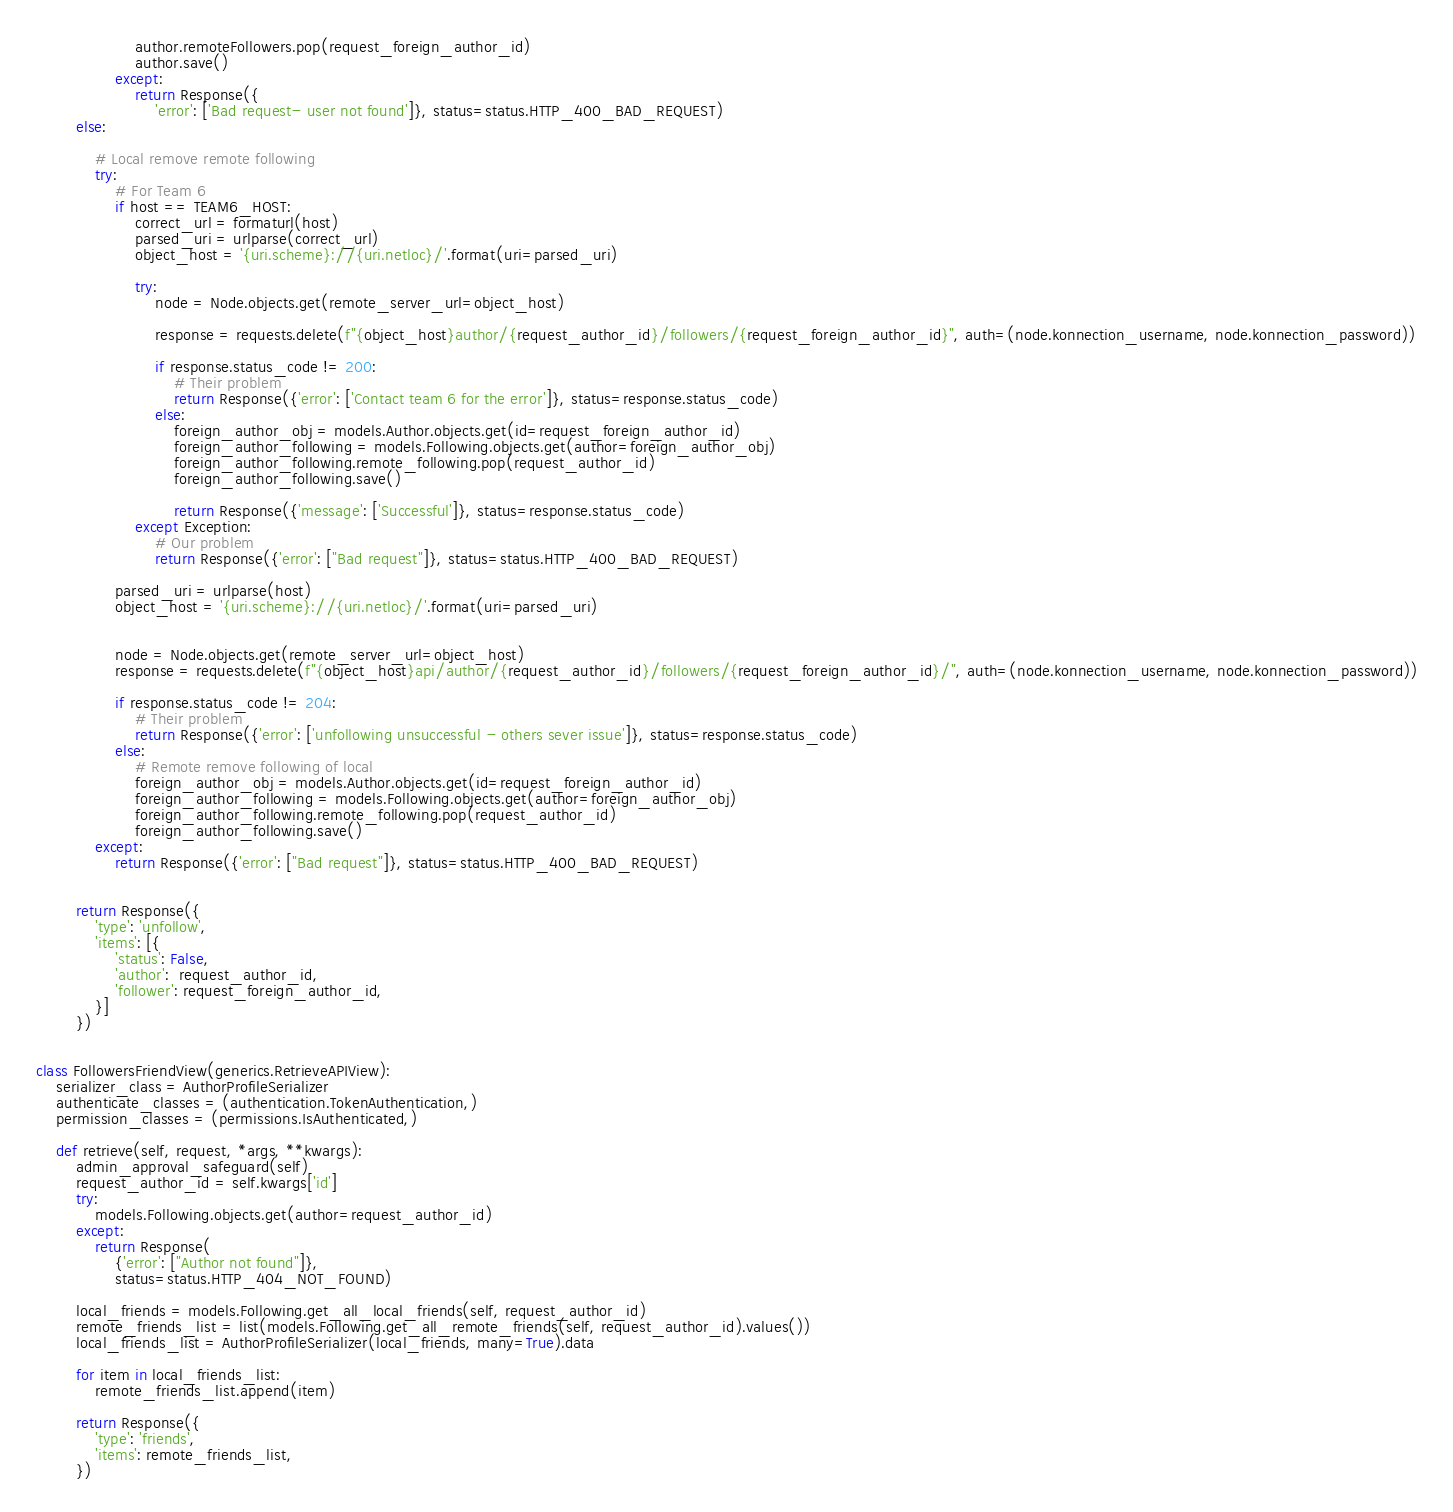<code> <loc_0><loc_0><loc_500><loc_500><_Python_>                    author.remoteFollowers.pop(request_foreign_author_id)
                    author.save()
                except:
                    return Response({
                        'error': ['Bad request- user not found']}, status=status.HTTP_400_BAD_REQUEST)
        else:
            
            # Local remove remote following
            try:
                # For Team 6
                if host == TEAM6_HOST:
                    correct_url = formaturl(host)
                    parsed_uri = urlparse(correct_url)
                    object_host = '{uri.scheme}://{uri.netloc}/'.format(uri=parsed_uri)

                    try:
                        node = Node.objects.get(remote_server_url=object_host)
                    
                        response = requests.delete(f"{object_host}author/{request_author_id}/followers/{request_foreign_author_id}", auth=(node.konnection_username, node.konnection_password))
                    
                        if response.status_code != 200:
                            # Their problem
                            return Response({'error': ['Contact team 6 for the error']}, status=response.status_code)
                        else:
                            foreign_author_obj = models.Author.objects.get(id=request_foreign_author_id)
                            foreign_author_following = models.Following.objects.get(author=foreign_author_obj)
                            foreign_author_following.remote_following.pop(request_author_id)
                            foreign_author_following.save()
    
                            return Response({'message': ['Successful']}, status=response.status_code)
                    except Exception:
                        # Our problem
                        return Response({'error': ["Bad request"]}, status=status.HTTP_400_BAD_REQUEST)

                parsed_uri = urlparse(host)
                object_host = '{uri.scheme}://{uri.netloc}/'.format(uri=parsed_uri)
                
   
                node = Node.objects.get(remote_server_url=object_host)
                response = requests.delete(f"{object_host}api/author/{request_author_id}/followers/{request_foreign_author_id}/", auth=(node.konnection_username, node.konnection_password))

                if response.status_code != 204:
                    # Their problem
                    return Response({'error': ['unfollowing unsuccessful - others sever issue']}, status=response.status_code)
                else:
                    # Remote remove following of local
                    foreign_author_obj = models.Author.objects.get(id=request_foreign_author_id)
                    foreign_author_following = models.Following.objects.get(author=foreign_author_obj)
                    foreign_author_following.remote_following.pop(request_author_id)
                    foreign_author_following.save()
            except:
                return Response({'error': ["Bad request"]}, status=status.HTTP_400_BAD_REQUEST)
            

        return Response({
            'type': 'unfollow',
            'items': [{
                'status': False,
                'author':  request_author_id,
                'follower': request_foreign_author_id,
            }]
        })


class FollowersFriendView(generics.RetrieveAPIView):
    serializer_class = AuthorProfileSerializer
    authenticate_classes = (authentication.TokenAuthentication,)
    permission_classes = (permissions.IsAuthenticated,)

    def retrieve(self, request, *args, **kwargs):
        admin_approval_safeguard(self)
        request_author_id = self.kwargs['id']
        try:
            models.Following.objects.get(author=request_author_id)
        except:
            return Response(
                {'error': ["Author not found"]},
                status=status.HTTP_404_NOT_FOUND)

        local_friends = models.Following.get_all_local_friends(self, request_author_id)
        remote_friends_list = list(models.Following.get_all_remote_friends(self, request_author_id).values())
        local_friends_list = AuthorProfileSerializer(local_friends, many=True).data  
        
        for item in local_friends_list:
            remote_friends_list.append(item)

        return Response({
            'type': 'friends',
            'items': remote_friends_list,
        })
</code> 